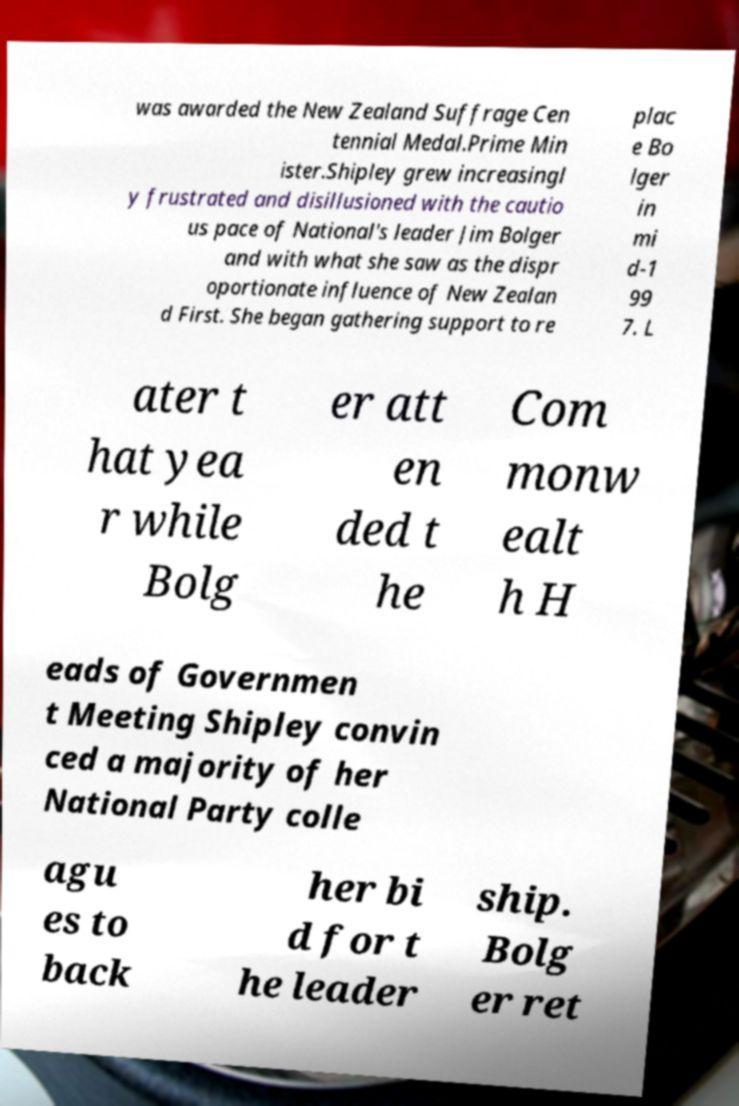Can you accurately transcribe the text from the provided image for me? was awarded the New Zealand Suffrage Cen tennial Medal.Prime Min ister.Shipley grew increasingl y frustrated and disillusioned with the cautio us pace of National's leader Jim Bolger and with what she saw as the dispr oportionate influence of New Zealan d First. She began gathering support to re plac e Bo lger in mi d-1 99 7. L ater t hat yea r while Bolg er att en ded t he Com monw ealt h H eads of Governmen t Meeting Shipley convin ced a majority of her National Party colle agu es to back her bi d for t he leader ship. Bolg er ret 